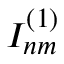Convert formula to latex. <formula><loc_0><loc_0><loc_500><loc_500>I _ { n m } ^ { ( 1 ) }</formula> 